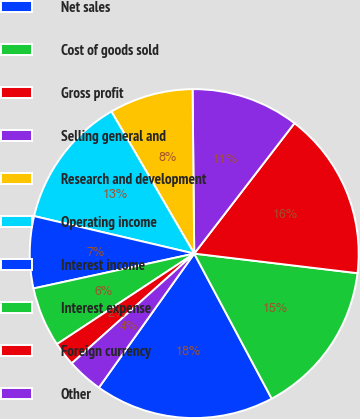<chart> <loc_0><loc_0><loc_500><loc_500><pie_chart><fcel>Net sales<fcel>Cost of goods sold<fcel>Gross profit<fcel>Selling general and<fcel>Research and development<fcel>Operating income<fcel>Interest income<fcel>Interest expense<fcel>Foreign currency<fcel>Other<nl><fcel>17.65%<fcel>15.29%<fcel>16.47%<fcel>10.59%<fcel>8.24%<fcel>12.94%<fcel>7.06%<fcel>5.88%<fcel>2.35%<fcel>3.53%<nl></chart> 